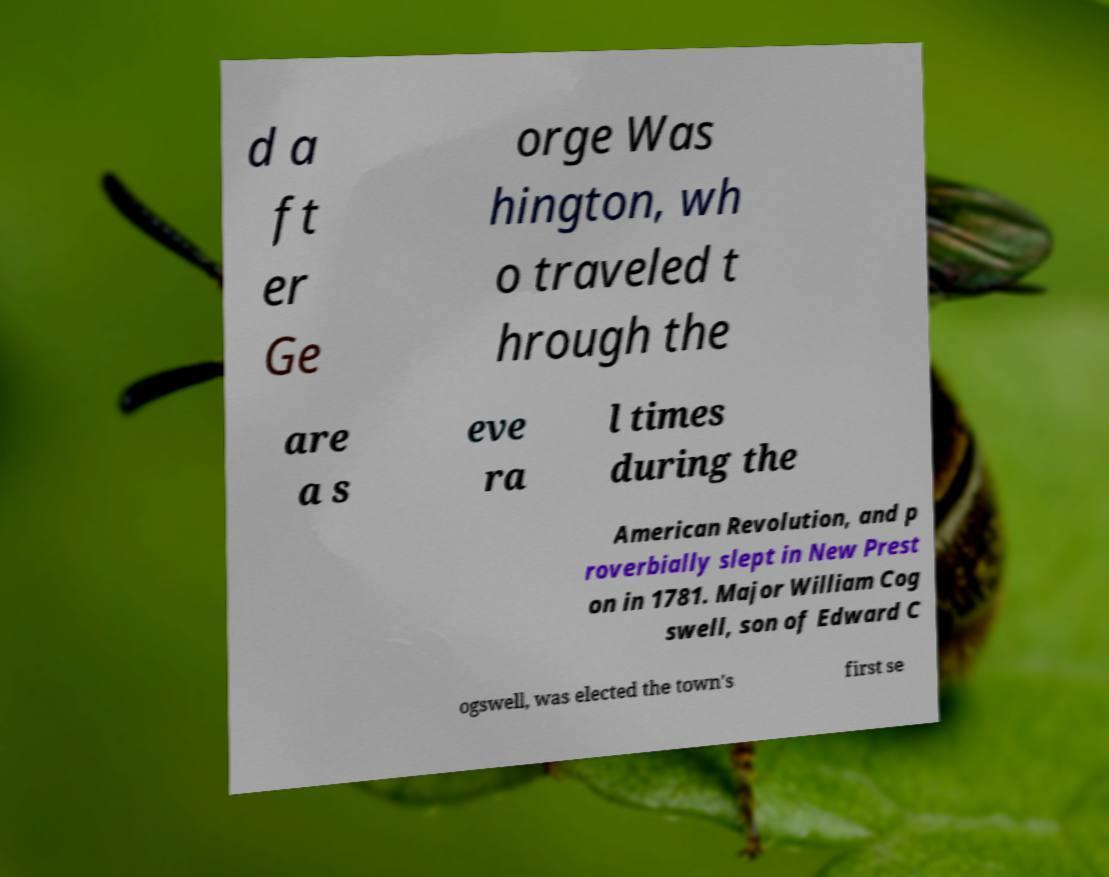Could you assist in decoding the text presented in this image and type it out clearly? d a ft er Ge orge Was hington, wh o traveled t hrough the are a s eve ra l times during the American Revolution, and p roverbially slept in New Prest on in 1781. Major William Cog swell, son of Edward C ogswell, was elected the town's first se 